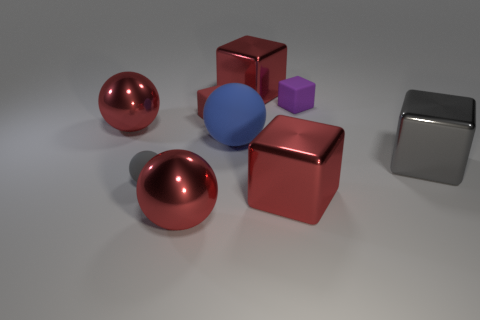Subtract all blue spheres. How many red blocks are left? 3 Subtract all gray cubes. How many cubes are left? 4 Subtract all gray shiny blocks. How many blocks are left? 4 Subtract all cyan blocks. Subtract all red cylinders. How many blocks are left? 5 Subtract all cubes. How many objects are left? 4 Add 6 big gray blocks. How many big gray blocks exist? 7 Subtract 3 red blocks. How many objects are left? 6 Subtract all red metal balls. Subtract all tiny red things. How many objects are left? 6 Add 4 blue spheres. How many blue spheres are left? 5 